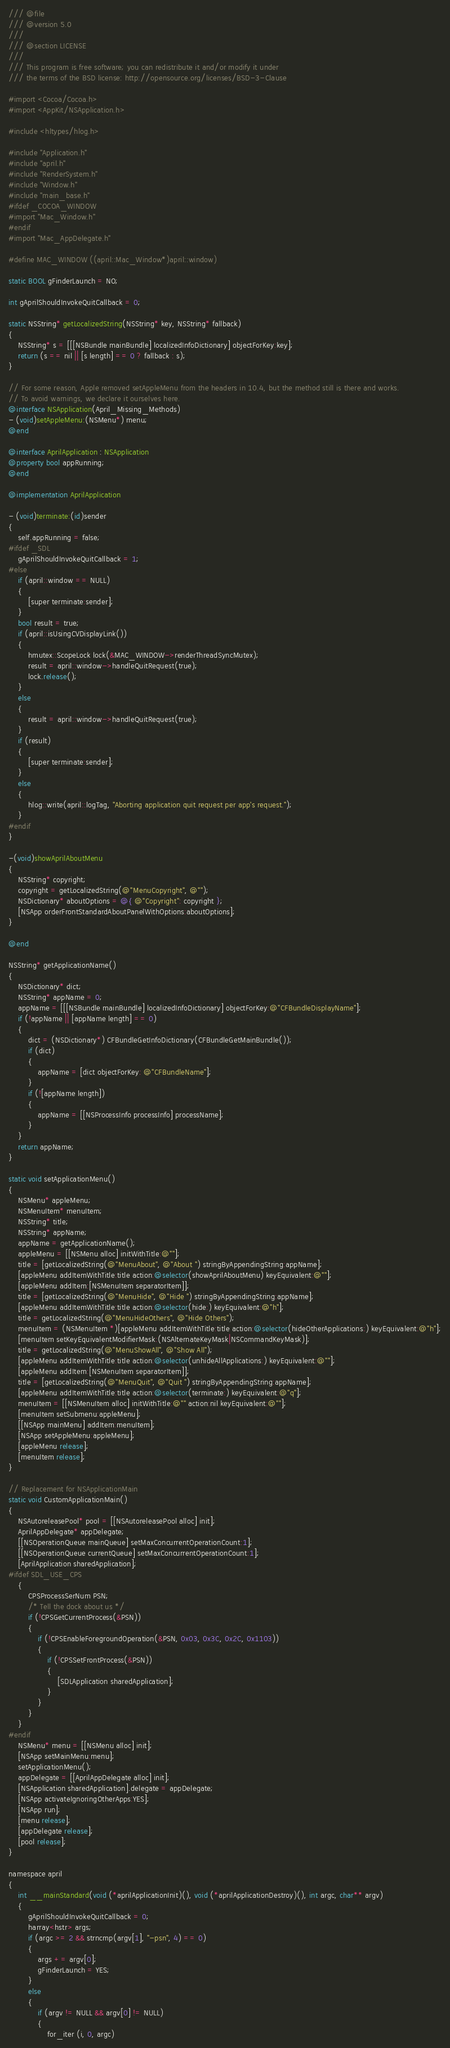<code> <loc_0><loc_0><loc_500><loc_500><_ObjectiveC_>/// @file
/// @version 5.0
/// 
/// @section LICENSE
/// 
/// This program is free software; you can redistribute it and/or modify it under
/// the terms of the BSD license: http://opensource.org/licenses/BSD-3-Clause

#import <Cocoa/Cocoa.h>
#import <AppKit/NSApplication.h>

#include <hltypes/hlog.h>

#include "Application.h"
#include "april.h"
#include "RenderSystem.h"
#include "Window.h"
#include "main_base.h"
#ifdef _COCOA_WINDOW
#import "Mac_Window.h"
#endif
#import "Mac_AppDelegate.h"

#define MAC_WINDOW ((april::Mac_Window*)april::window)

static BOOL gFinderLaunch = NO;

int gAprilShouldInvokeQuitCallback = 0;

static NSString* getLocalizedString(NSString* key, NSString* fallback)
{
	NSString* s = [[[NSBundle mainBundle] localizedInfoDictionary] objectForKey:key];
	return (s == nil || [s length] == 0 ? fallback : s);
}

// For some reason, Apple removed setAppleMenu from the headers in 10.4, but the method still is there and works.
// To avoid warnings, we declare it ourselves here.
@interface NSApplication(April_Missing_Methods)
- (void)setAppleMenu:(NSMenu*) menu;
@end

@interface AprilApplication : NSApplication
@property bool appRunning;
@end

@implementation AprilApplication

- (void)terminate:(id)sender
{
	self.appRunning = false;
#ifdef _SDL
	gAprilShouldInvokeQuitCallback = 1;
#else
	if (april::window == NULL)
	{
		[super terminate:sender];
	}
	bool result = true;
	if (april::isUsingCVDisplayLink())
	{
		hmutex::ScopeLock lock(&MAC_WINDOW->renderThreadSyncMutex);
		result = april::window->handleQuitRequest(true);
		lock.release();
	}
	else
	{
		result = april::window->handleQuitRequest(true);
	}
	if (result)
	{
		[super terminate:sender];
	}
	else
	{
		hlog::write(april::logTag, "Aborting application quit request per app's request.");
	}	
#endif
}

-(void)showAprilAboutMenu
{
	NSString* copyright;
	copyright = getLocalizedString(@"MenuCopyright", @"");
	NSDictionary* aboutOptions = @{ @"Copyright": copyright };
	[NSApp orderFrontStandardAboutPanelWithOptions:aboutOptions];
}

@end

NSString* getApplicationName()
{
	NSDictionary* dict;
	NSString* appName = 0;
	appName = [[[NSBundle mainBundle] localizedInfoDictionary] objectForKey:@"CFBundleDisplayName"];
	if (!appName || [appName length] == 0)
	{
		dict = (NSDictionary*) CFBundleGetInfoDictionary(CFBundleGetMainBundle());
		if (dict)
		{
			appName = [dict objectForKey: @"CFBundleName"];
		}
		if (![appName length])
		{
			appName = [[NSProcessInfo processInfo] processName];
		}
	}
	return appName;
}

static void setApplicationMenu()
{
	NSMenu* appleMenu;
	NSMenuItem* menuItem;
	NSString* title;
	NSString* appName;
	appName = getApplicationName();
	appleMenu = [[NSMenu alloc] initWithTitle:@""];
	title = [getLocalizedString(@"MenuAbout", @"About ") stringByAppendingString:appName];
	[appleMenu addItemWithTitle:title action:@selector(showAprilAboutMenu) keyEquivalent:@""];
	[appleMenu addItem:[NSMenuItem separatorItem]];
	title = [getLocalizedString(@"MenuHide", @"Hide ") stringByAppendingString:appName];
	[appleMenu addItemWithTitle:title action:@selector(hide:) keyEquivalent:@"h"];
	title = getLocalizedString(@"MenuHideOthers", @"Hide Others");
	menuItem = (NSMenuItem *)[appleMenu addItemWithTitle:title action:@selector(hideOtherApplications:) keyEquivalent:@"h"];
	[menuItem setKeyEquivalentModifierMask:(NSAlternateKeyMask|NSCommandKeyMask)];
	title = getLocalizedString(@"MenuShowAll", @"Show All");
	[appleMenu addItemWithTitle:title action:@selector(unhideAllApplications:) keyEquivalent:@""];
	[appleMenu addItem:[NSMenuItem separatorItem]];
	title = [getLocalizedString(@"MenuQuit", @"Quit ") stringByAppendingString:appName];
	[appleMenu addItemWithTitle:title action:@selector(terminate:) keyEquivalent:@"q"];
	menuItem = [[NSMenuItem alloc] initWithTitle:@"" action:nil keyEquivalent:@""];
	[menuItem setSubmenu:appleMenu];
	[[NSApp mainMenu] addItem:menuItem];
	[NSApp setAppleMenu:appleMenu];
	[appleMenu release];
	[menuItem release];
}

// Replacement for NSApplicationMain
static void CustomApplicationMain()
{
	NSAutoreleasePool* pool = [[NSAutoreleasePool alloc] init];
	AprilAppDelegate* appDelegate;
	[[NSOperationQueue mainQueue] setMaxConcurrentOperationCount:1];
	[[NSOperationQueue currentQueue] setMaxConcurrentOperationCount:1];
	[AprilApplication sharedApplication];
#ifdef SDL_USE_CPS
	{
		CPSProcessSerNum PSN;
		/* Tell the dock about us */
		if (!CPSGetCurrentProcess(&PSN))
		{
			if (!CPSEnableForegroundOperation(&PSN, 0x03, 0x3C, 0x2C, 0x1103))
			{
				if (!CPSSetFrontProcess(&PSN))
				{
					[SDLApplication sharedApplication];
				}
			}
		}
	}
#endif
	NSMenu* menu = [[NSMenu alloc] init];
	[NSApp setMainMenu:menu];
	setApplicationMenu();
	appDelegate = [[AprilAppDelegate alloc] init];
	[NSApplication sharedApplication].delegate = appDelegate;
	[NSApp activateIgnoringOtherApps:YES];
	[NSApp run];
	[menu release];
	[appDelegate release];
	[pool release];
}

namespace april
{
	int __mainStandard(void (*aprilApplicationInit)(), void (*aprilApplicationDestroy)(), int argc, char** argv)
	{
		gAprilShouldInvokeQuitCallback = 0;
		harray<hstr> args;
		if (argc >= 2 && strncmp(argv[1], "-psn", 4) == 0)
		{
			args += argv[0];
			gFinderLaunch = YES;
		}
		else
		{
			if (argv != NULL && argv[0] != NULL)
			{
				for_iter (i, 0, argc)</code> 